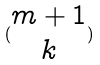Convert formula to latex. <formula><loc_0><loc_0><loc_500><loc_500>( \begin{matrix} m + 1 \\ k \end{matrix} )</formula> 